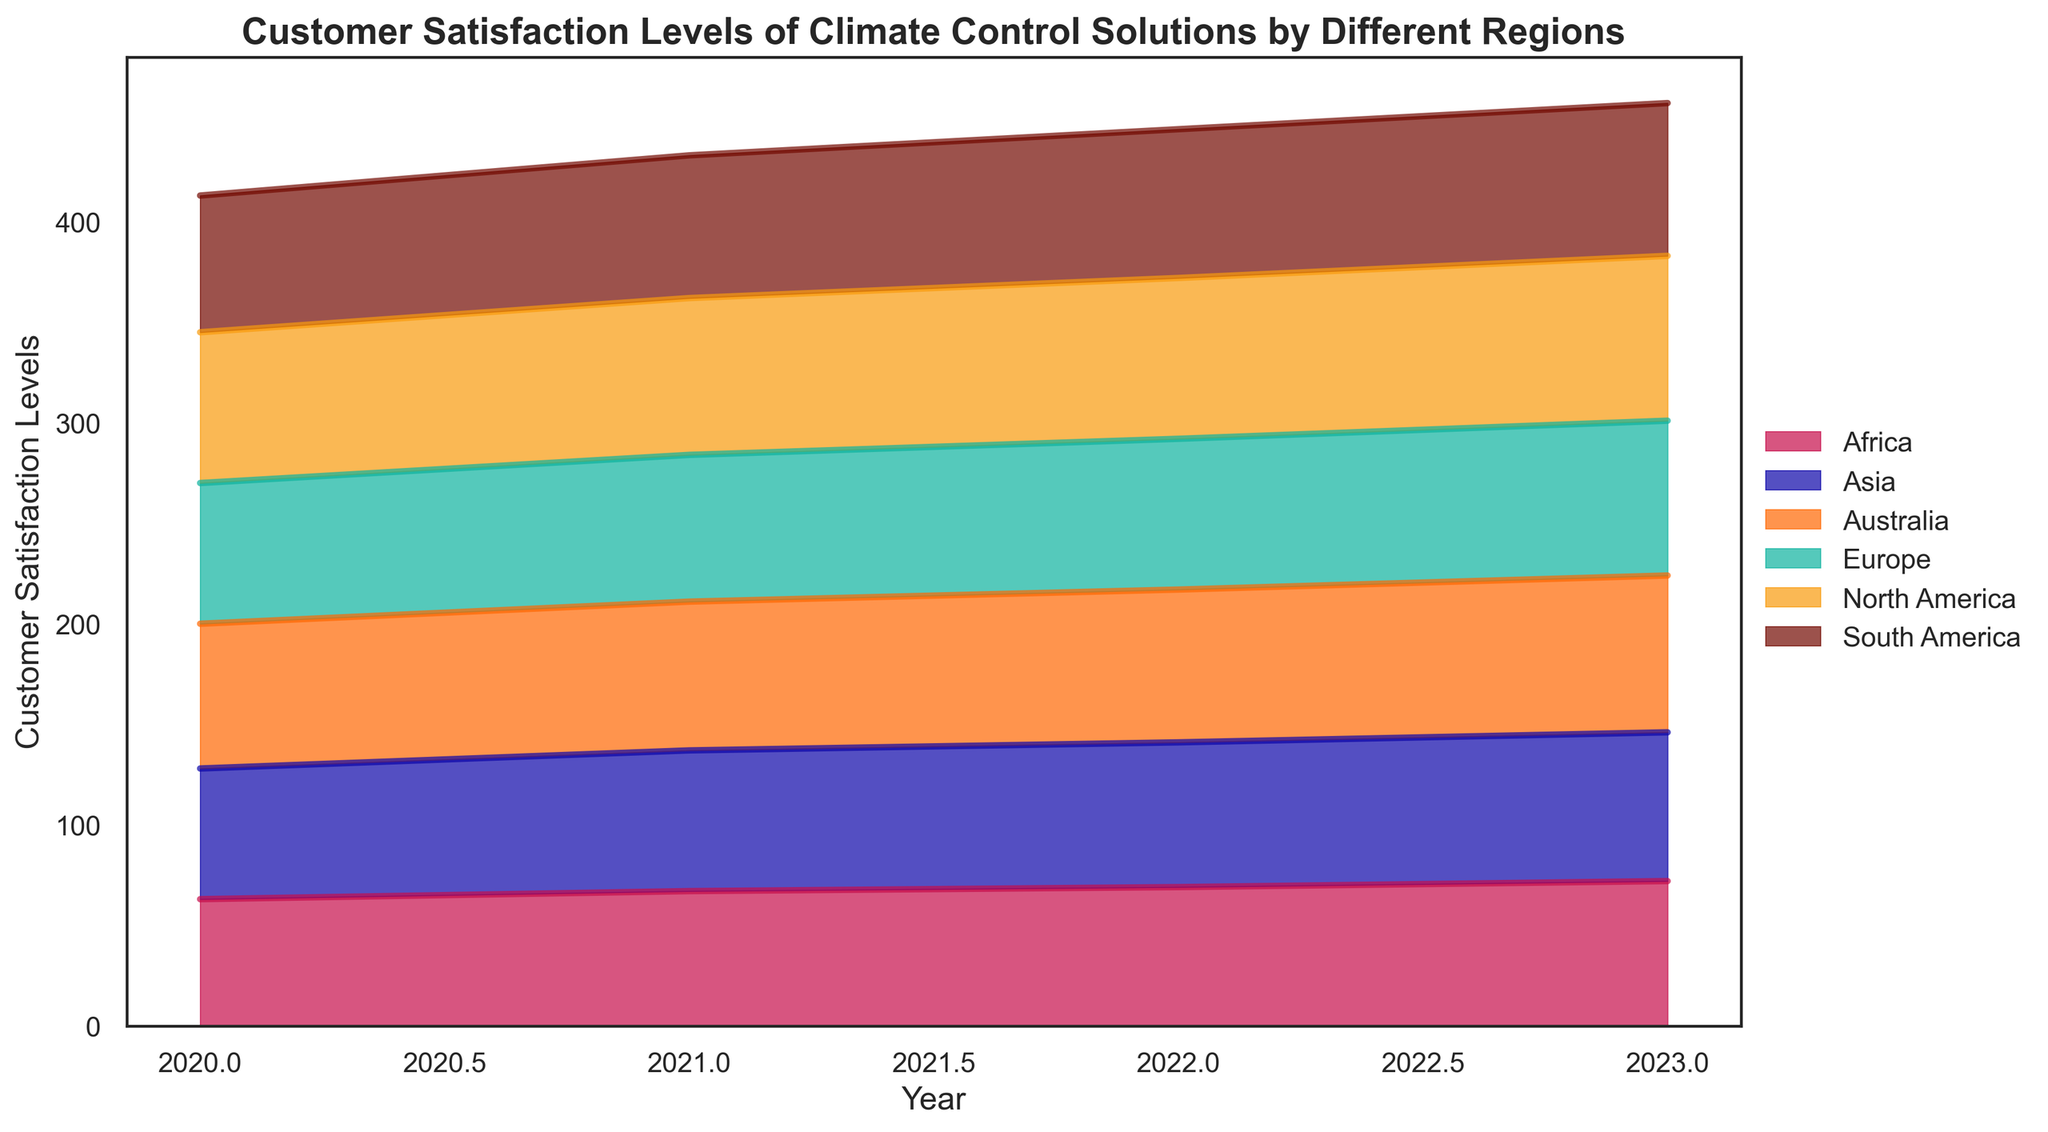What is the general trend of customer satisfaction in North America from 2020 to 2023? The customer satisfaction levels in North America show an increasing trend over the years. From 2020 to 2023, satisfaction levels increase from 75 to 82.
Answer: Increasing Which region had the highest customer satisfaction level in 2023? By examining the heights of the areas in the chart at the 2023 mark, we see that North America has the highest satisfaction level at 82.
Answer: North America Compare the customer satisfaction levels in Asia and Africa in 2021. Which one is higher? By comparing the 2021 values for both regions on the chart, Asia is at 70 while Africa is at 67. Asia has higher satisfaction in 2021.
Answer: Asia What is the difference in customer satisfaction levels between Europe and South America in 2022? The satisfaction level in 2022 for Europe is 75 while for South America it is 74. The difference is 75 - 74 = 1.
Answer: 1 What is the average customer satisfaction level in Europe over the four years? Sum the satisfaction levels from 2020 to 2023 in Europe and divide by 4. (70 + 73 + 75 + 77) / 4 = 73.75.
Answer: 73.75 Among all regions, which one showed the most improvement in customer satisfaction from 2020 to 2023? Calculate the difference for each region from 2020 to 2023 and compare. North America: 82 - 75 = 7, Europe: 77 - 70 = 7, Asia: 74 - 65 = 9, South America: 76 - 68 = 8, Africa: 72 - 63 = 9, Australia: 78 - 72 = 6. Asia and Africa showed the most improvement with an increase of 9.
Answer: Asia and Africa What is the combined customer satisfaction level for Australia and South America in 2023? Add the satisfaction levels of Australia and South America for 2023. Australia: 78, South America: 76. Combined score = 78 + 76 = 154
Answer: 154 How has customer satisfaction in Africa changed from 2021 to 2023? From the chart, Africa's customer satisfaction level in 2021 is 67, and it rises to 72 in 2023. The increase is 72 - 67 = 5.
Answer: Increased by 5 Which two regions have the closest customer satisfaction levels in 2020? In 2020, compare all regions' values: North America (75), Europe (70), Asia (65), South America (68), Africa (63), Australia (72). The closest values are Europe (70) and Australia (72), with a difference of 2.
Answer: Europe and Australia What is the total customer satisfaction sum for all regions in 2022? Sum the satisfaction levels for all regions in 2022: North America (80), Europe (75), Asia (72), South America (74), Africa (69), Australia (76). Total sum = 80 + 75 + 72 + 74 + 69 + 76 = 446.
Answer: 446 